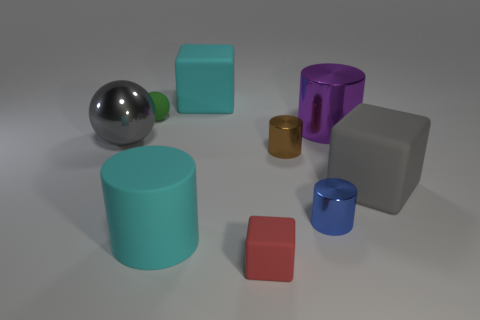Is the big gray object on the right side of the gray ball made of the same material as the blue object?
Give a very brief answer. No. Are there the same number of blue cylinders that are behind the brown metal thing and tiny green matte things in front of the big gray metal ball?
Provide a succinct answer. Yes. What is the material of the thing that is the same color as the large matte cylinder?
Your answer should be compact. Rubber. How many shiny cylinders are behind the big cube in front of the purple object?
Provide a succinct answer. 2. Is the color of the ball that is left of the tiny green rubber thing the same as the small thing that is behind the brown thing?
Keep it short and to the point. No. What is the material of the other cylinder that is the same size as the purple cylinder?
Your answer should be very brief. Rubber. What shape is the big metallic thing that is to the right of the red cube in front of the large matte block that is to the left of the red rubber thing?
Your answer should be compact. Cylinder. The gray matte thing that is the same size as the purple shiny thing is what shape?
Make the answer very short. Cube. How many shiny cylinders are left of the large cyan rubber thing behind the matte thing to the left of the large cyan cylinder?
Give a very brief answer. 0. Are there more cyan matte things that are in front of the cyan rubber cube than brown shiny cylinders that are right of the blue metallic thing?
Provide a succinct answer. Yes. 